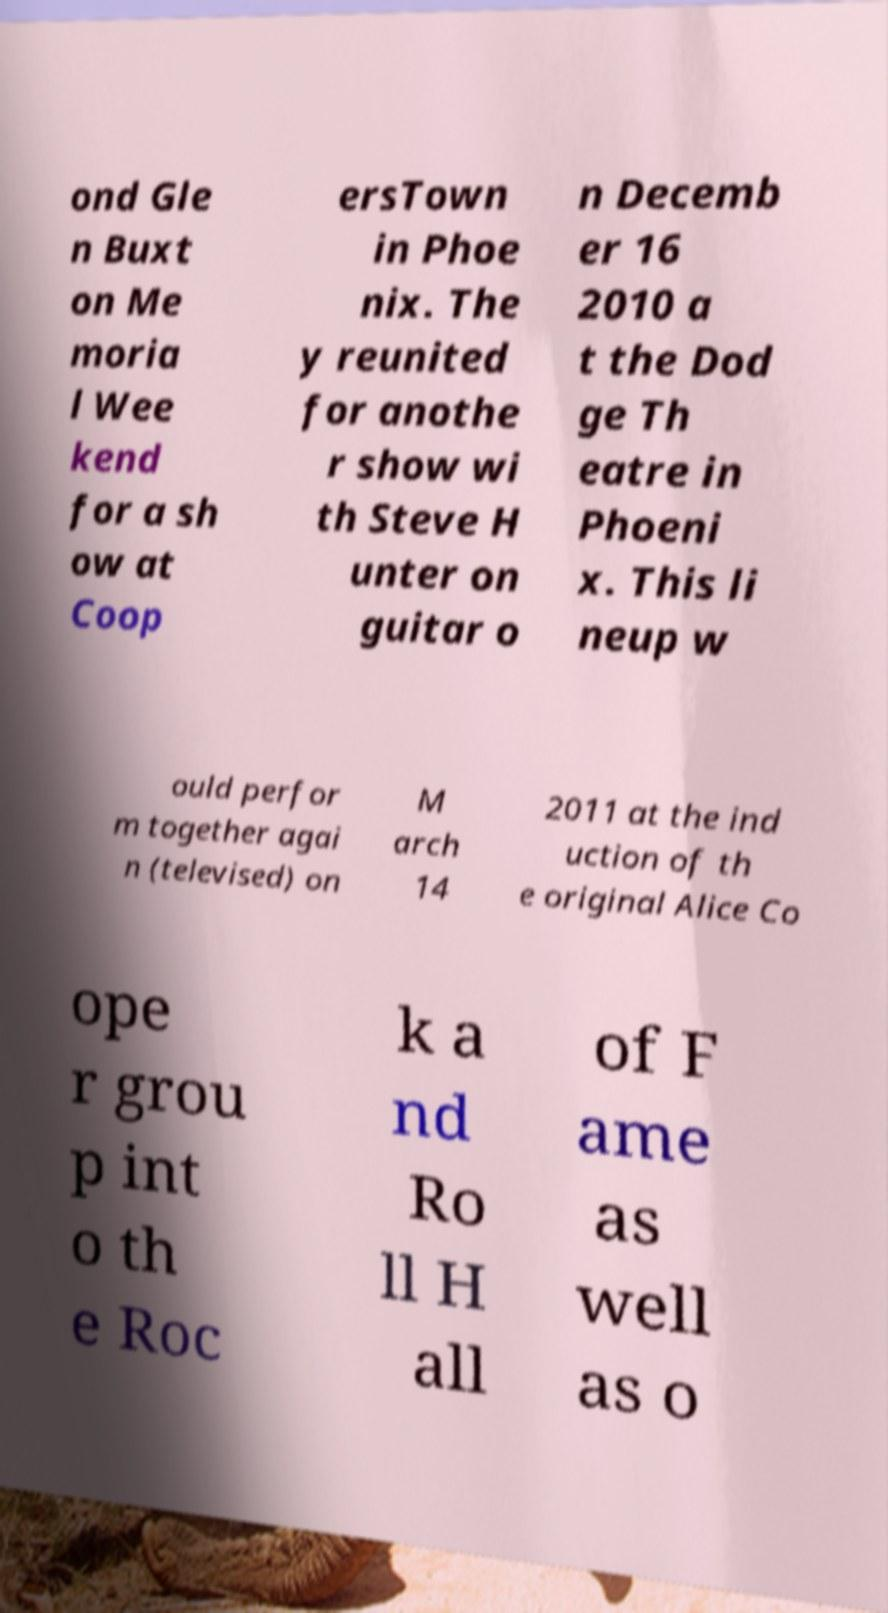Can you read and provide the text displayed in the image?This photo seems to have some interesting text. Can you extract and type it out for me? ond Gle n Buxt on Me moria l Wee kend for a sh ow at Coop ersTown in Phoe nix. The y reunited for anothe r show wi th Steve H unter on guitar o n Decemb er 16 2010 a t the Dod ge Th eatre in Phoeni x. This li neup w ould perfor m together agai n (televised) on M arch 14 2011 at the ind uction of th e original Alice Co ope r grou p int o th e Roc k a nd Ro ll H all of F ame as well as o 